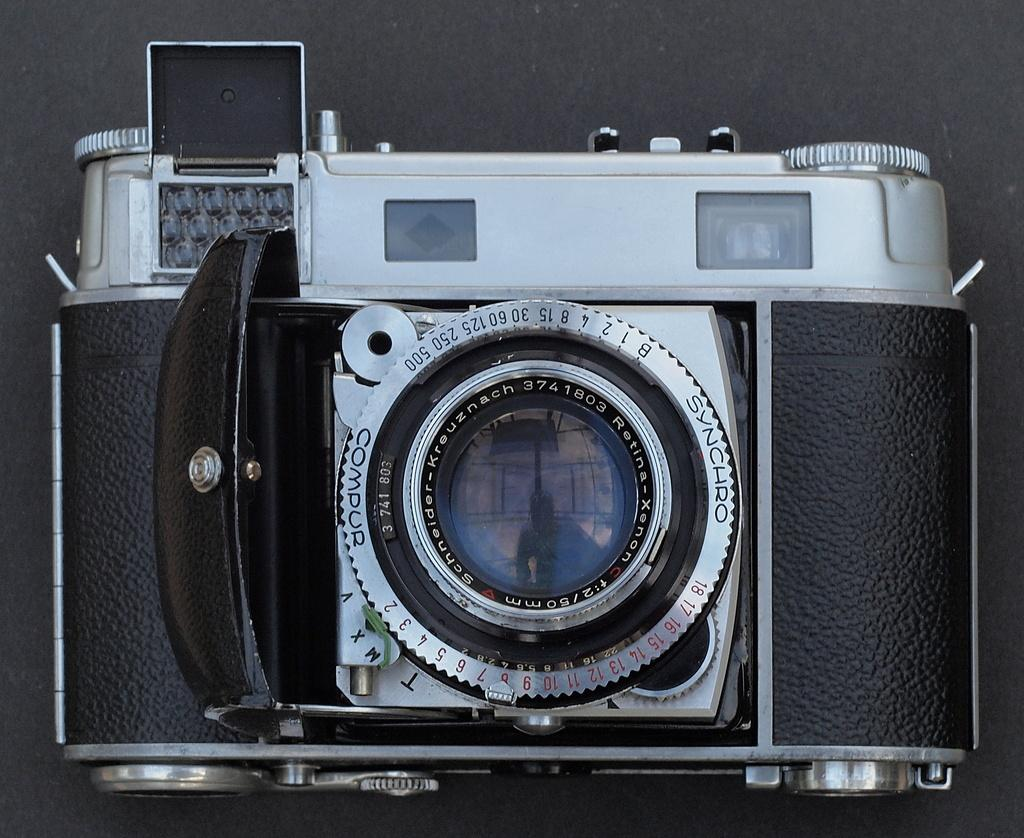What object is the main subject of the image? There is a camera in the image. What colors can be seen on the camera? The camera is black and silver in color. What can be seen in the background of the image? The background of the image is black. How many hats are visible in the image? There are no hats visible in the image. --- Facts: 1. There is a person in the image. 2. The person is wearing a hat. 3. The hat is red. 4. The person is holding a book. 5. The book is titled "The Adventures of Alice." Absurd Topics: elephant, piano, parrot Conversation: Who or what is the main subject of the image? The main subject of the image is a person. What is the person in the image wearing? The person in the image is wearing a red hat. What is the person in the image holding? The person in the image is holding a book titled "The Adventures of Alice." What color is the hat the person in the image is wearing? The hat the person in the image is wearing is red. What might the person in the image be doing? The person in the image might be reading the book they are holding. Reasoning: Let's think step by step in order to produce the conversation. We start by identifying the main subject of the image, which is a person. Then, we describe the person's attire, specifically mentioning the red hat they are wearing. Next, we observe the object the person in the image is holding, which is a book. We then describe the book's title, which is "The Adventures of Alice." Finally, we speculate on the person's possible activity, which is reading the book they are holding. Absurd Question/Answer: Can you hear the parrot singing in the image? There is no parrot present in the image, so it is not possible to hear a parrot singing. --- Facts: 1. There is a dog in the image. 2. The dog is brown. 3. The dog is sitting on a rug. 4. The rug has a floral pattern. 5. The background of the image is a living room. Absurd Topics: spaceship, basketball, soccer Conversation: What type of animal is in the image? There is a dog in the image. What color is the dog in the image? The dog in the image is brown. What is the dog in the image doing? The dog in the image is sitting on a rug. What is the pattern on the rug the dog in the image is sitting on? The rug the dog in the image is sitting on has a floral pattern. What might be the setting of the image? The background of the image is a living room. Reasoning: Let's think step by step in order to produce the conversation. 